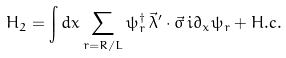<formula> <loc_0><loc_0><loc_500><loc_500>H _ { 2 } = \int d x \sum _ { r = R / L } \psi ^ { \dagger } _ { r } \, \vec { \lambda } ^ { \prime } \cdot \vec { \sigma } \, i \partial _ { x } \psi _ { r } + H . c .</formula> 